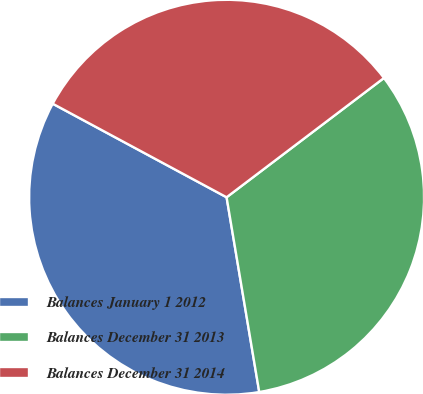Convert chart to OTSL. <chart><loc_0><loc_0><loc_500><loc_500><pie_chart><fcel>Balances January 1 2012<fcel>Balances December 31 2013<fcel>Balances December 31 2014<nl><fcel>35.5%<fcel>32.68%<fcel>31.82%<nl></chart> 